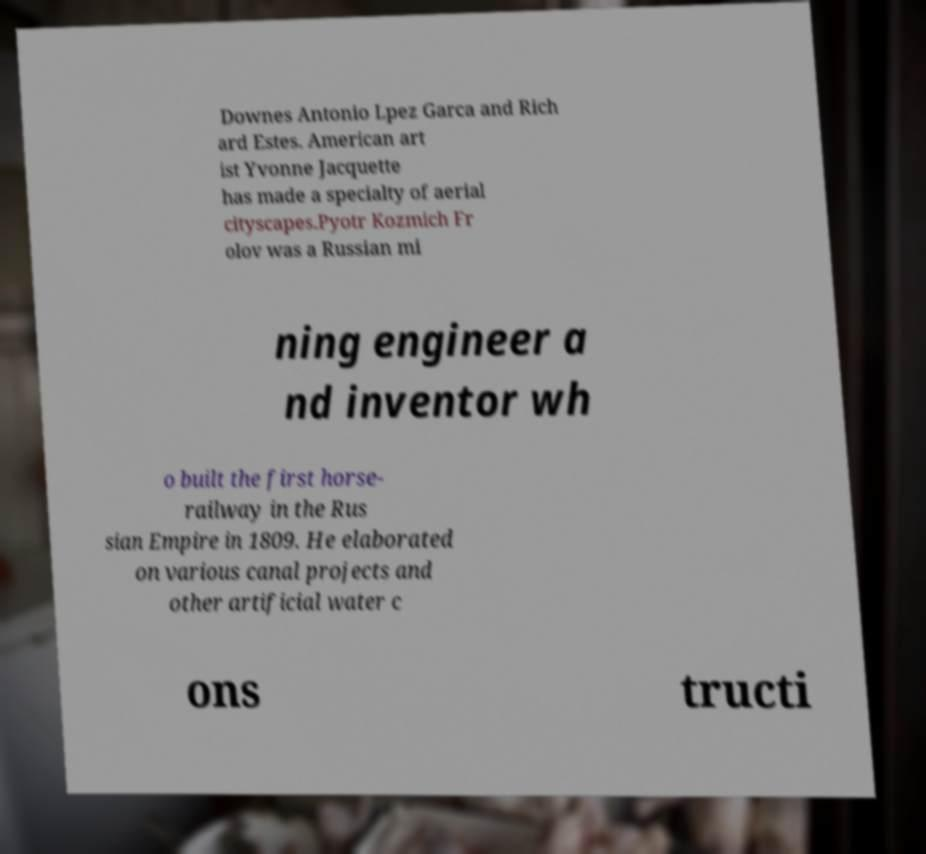Could you assist in decoding the text presented in this image and type it out clearly? Downes Antonio Lpez Garca and Rich ard Estes. American art ist Yvonne Jacquette has made a specialty of aerial cityscapes.Pyotr Kozmich Fr olov was a Russian mi ning engineer a nd inventor wh o built the first horse- railway in the Rus sian Empire in 1809. He elaborated on various canal projects and other artificial water c ons tructi 